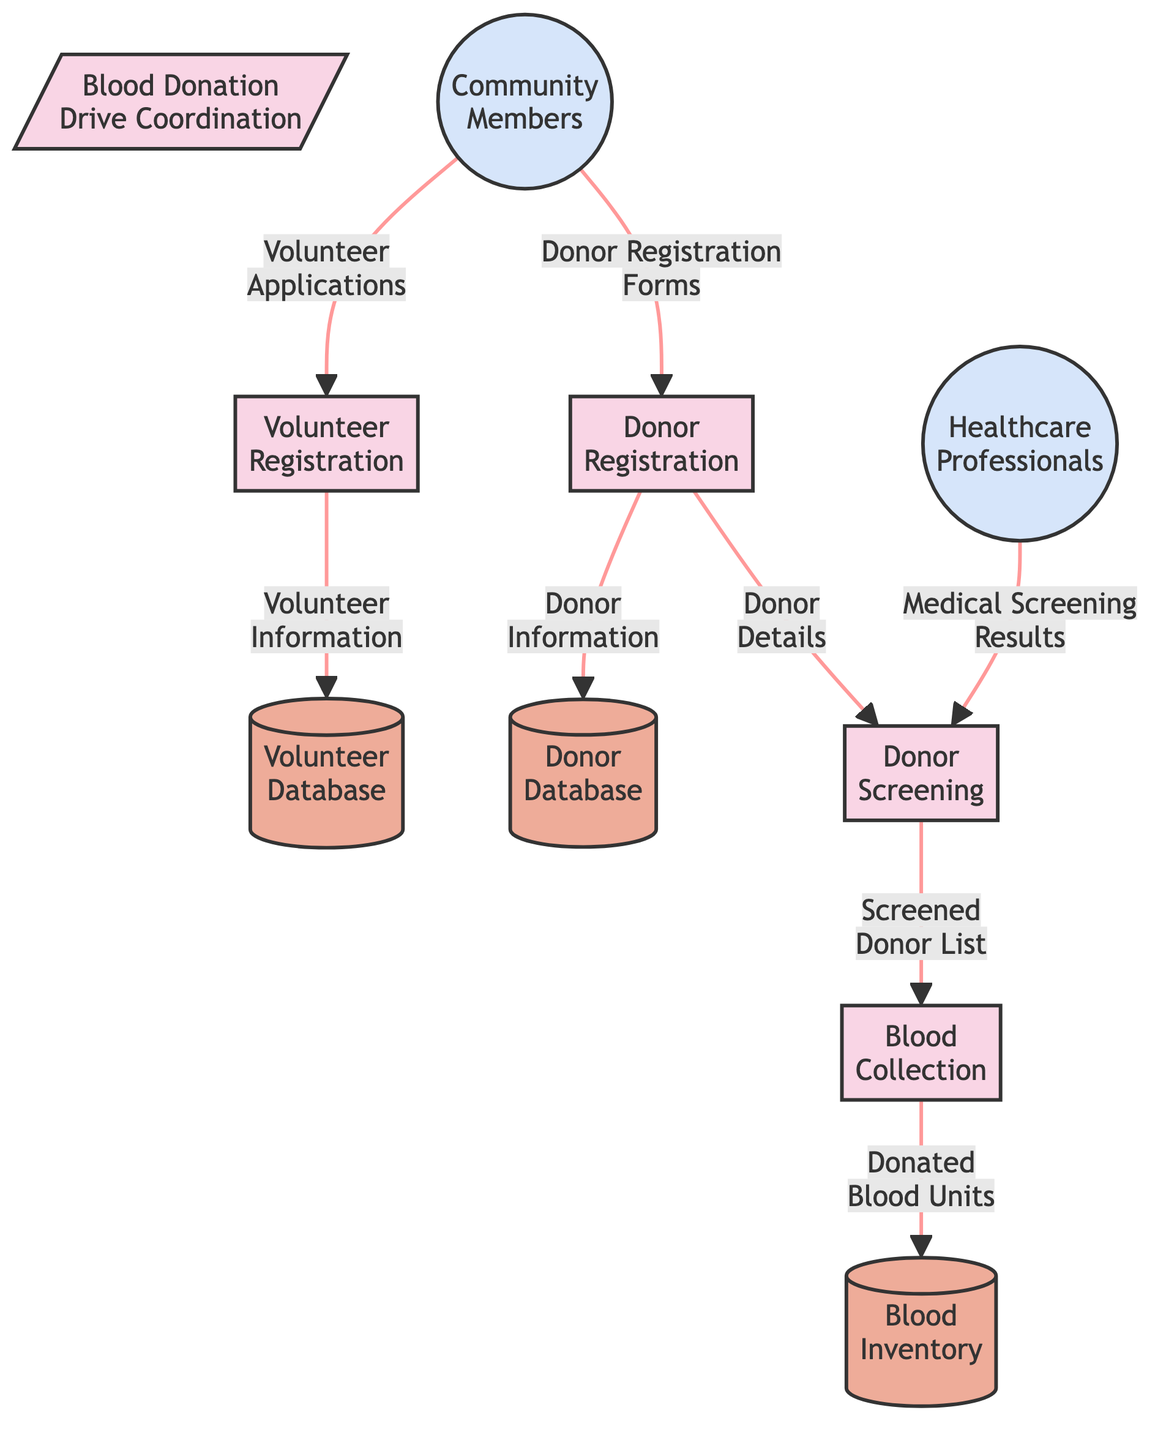What is the main process represented in this diagram? The diagram shows the primary process labeled as "Blood Donation Drive Coordination," indicated prominently at the top of the flowchart.
Answer: Blood Donation Drive Coordination How many processes are depicted in the diagram? By counting the items categorized under "processes" in the diagram, we find five distinct processes present.
Answer: 5 Which data store receives volunteer information? The data store identified as "Volunteer Database" is the destination for the flow named "Volunteer Information" that comes from the process "Volunteer Registration."
Answer: Volunteer Database What type of information is sent from "Donor Registration" to "Donor Database"? The flow is labeled "Donor Information," which means that the specific details provided during the donor registration process are sent to the Donor Database.
Answer: Donor Information What is the relationship between "Donor Screening" and "Blood Collection"? The connection between these two processes is represented by the flow called "Screened Donor List," which indicates that information about screened donors moves from the screening process to the collection process.
Answer: Screened Donor List What external entity sends volunteer applications? The entity labeled as "Community Members" sends in the flow named "Volunteer Applications," indicating their role in providing information for registration.
Answer: Community Members From which professional do "Medical Screening Results" flow into? The flow coming from the external entity "Healthcare Professionals" delivers the "Medical Screening Results" into the process of "Donor Screening."
Answer: Healthcare Professionals How many data stores are indicated in the diagram? The diagram displays three data stores, which are classified as "Volunteer Database," "Donor Database," and "Blood Inventory."
Answer: 3 What is the final destination of the donated blood units? The last data store indicated in the flow is labeled as "Blood Inventory," which receives the flow termed "Donated Blood Units" from the process "Blood Collection."
Answer: Blood Inventory 